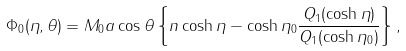Convert formula to latex. <formula><loc_0><loc_0><loc_500><loc_500>\Phi _ { 0 } ( \eta , \theta ) = M _ { 0 } a \cos { \theta } \left \{ n \cosh { \eta } - \cosh { \eta _ { 0 } } \frac { Q _ { 1 } ( \cosh { \eta } ) } { Q _ { 1 } ( \cosh { \eta _ { 0 } } ) } \right \} ,</formula> 